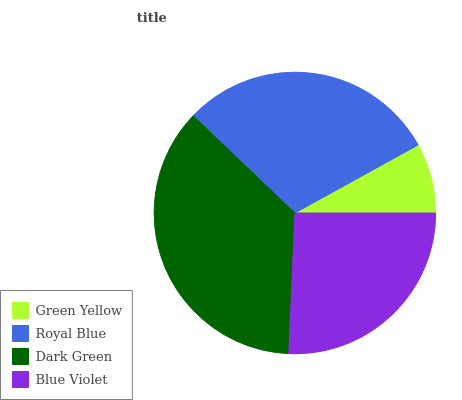Is Green Yellow the minimum?
Answer yes or no. Yes. Is Dark Green the maximum?
Answer yes or no. Yes. Is Royal Blue the minimum?
Answer yes or no. No. Is Royal Blue the maximum?
Answer yes or no. No. Is Royal Blue greater than Green Yellow?
Answer yes or no. Yes. Is Green Yellow less than Royal Blue?
Answer yes or no. Yes. Is Green Yellow greater than Royal Blue?
Answer yes or no. No. Is Royal Blue less than Green Yellow?
Answer yes or no. No. Is Royal Blue the high median?
Answer yes or no. Yes. Is Blue Violet the low median?
Answer yes or no. Yes. Is Green Yellow the high median?
Answer yes or no. No. Is Dark Green the low median?
Answer yes or no. No. 